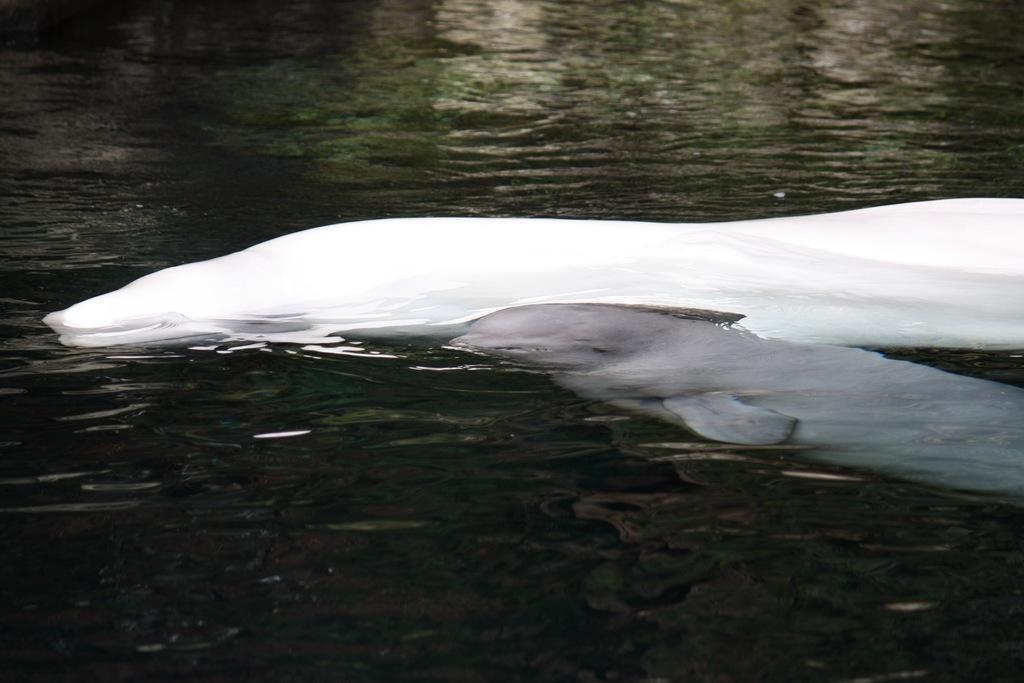Please provide a concise description of this image. In the image I can see two dolphins in the water. 